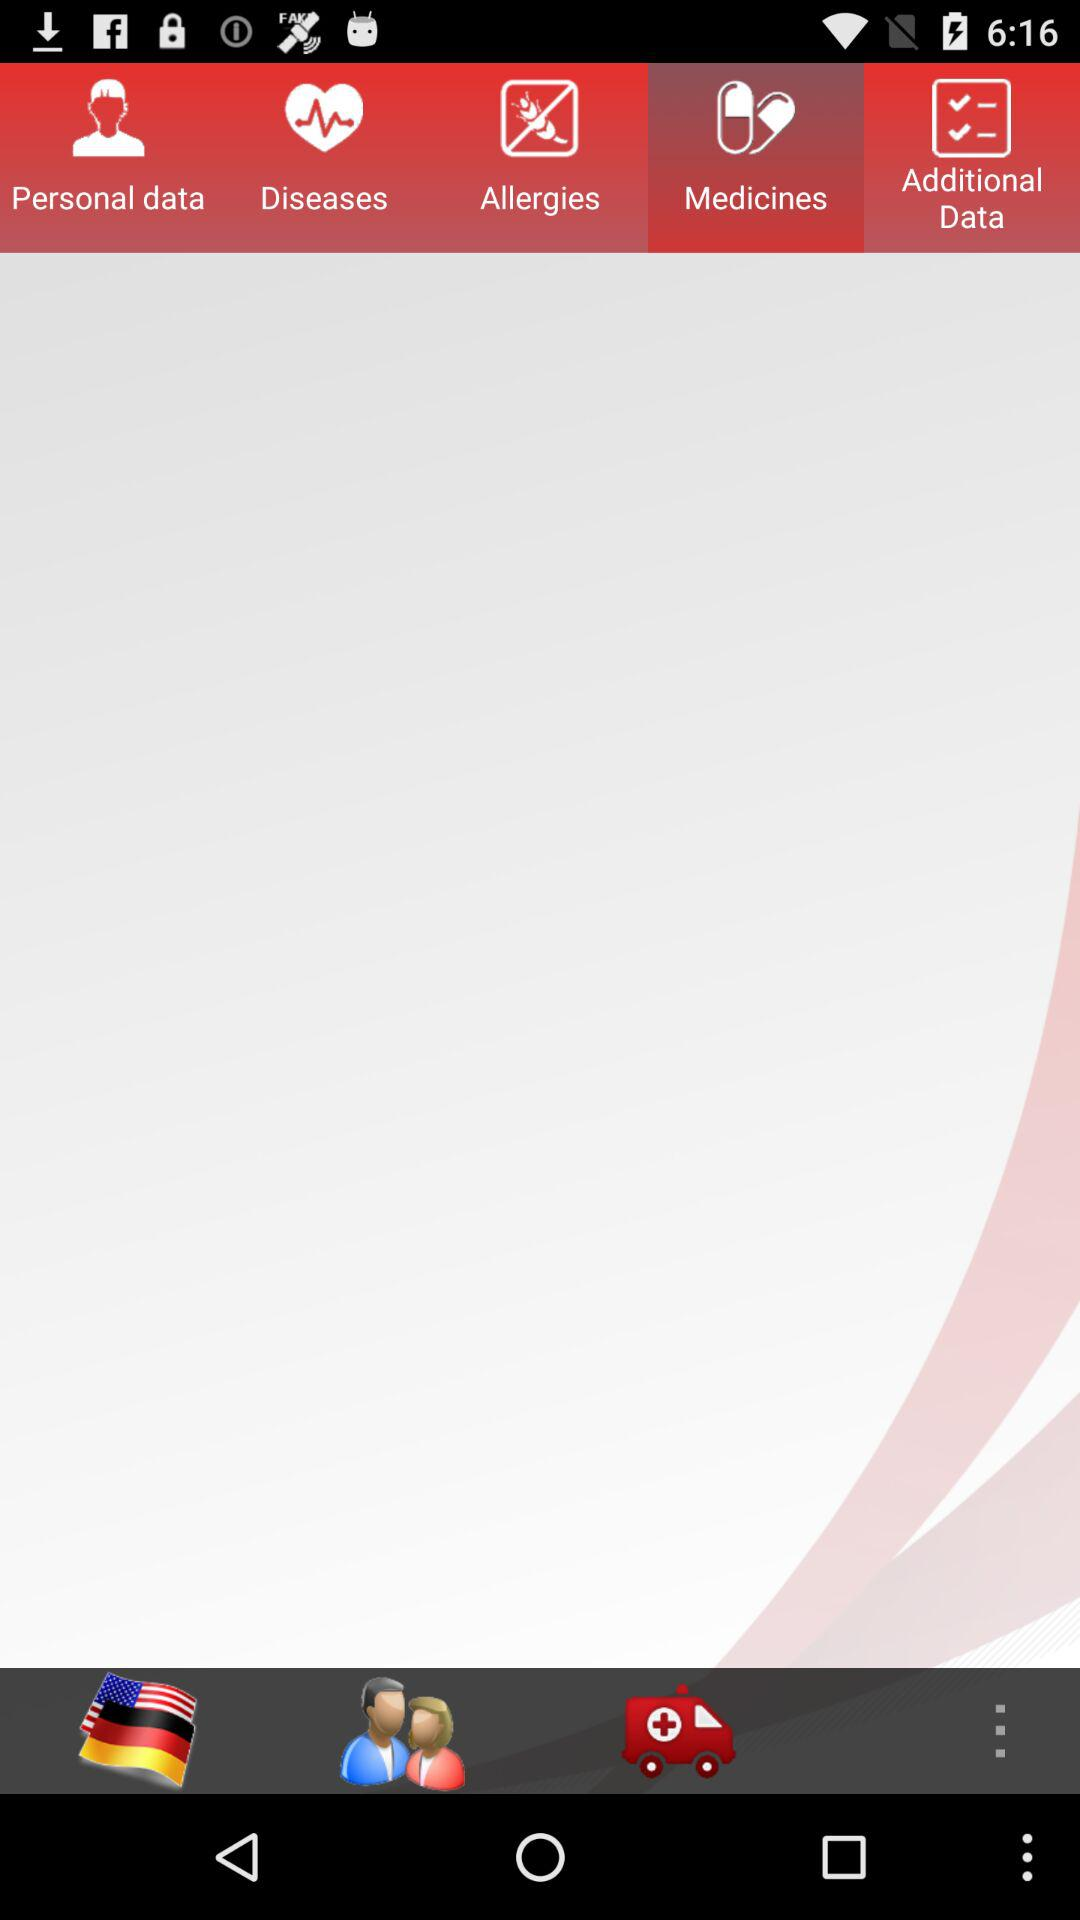Which tab has been selected? The selected tab is "Medicines". 